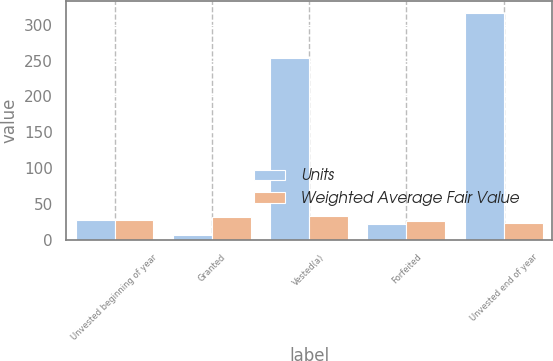Convert chart to OTSL. <chart><loc_0><loc_0><loc_500><loc_500><stacked_bar_chart><ecel><fcel>Unvested beginning of year<fcel>Granted<fcel>Vested(a)<fcel>Forfeited<fcel>Unvested end of year<nl><fcel>Units<fcel>27.61<fcel>6<fcel>253<fcel>22<fcel>317<nl><fcel>Weighted Average Fair Value<fcel>27.61<fcel>31.65<fcel>32.62<fcel>26.12<fcel>23.6<nl></chart> 